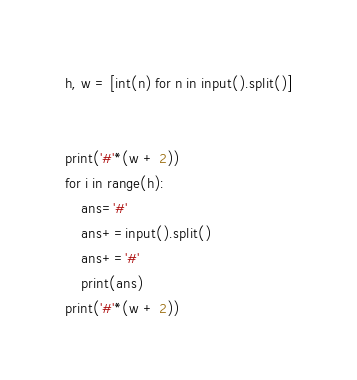<code> <loc_0><loc_0><loc_500><loc_500><_Python_>h, w = [int(n) for n in input().split()]


print('#'*(w + 2))
for i in range(h):
    ans='#'
    ans+=input().split()
    ans+='#'
    print(ans)
print('#'*(w + 2))</code> 